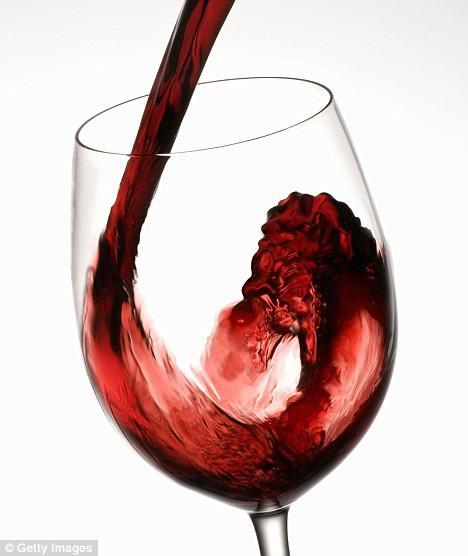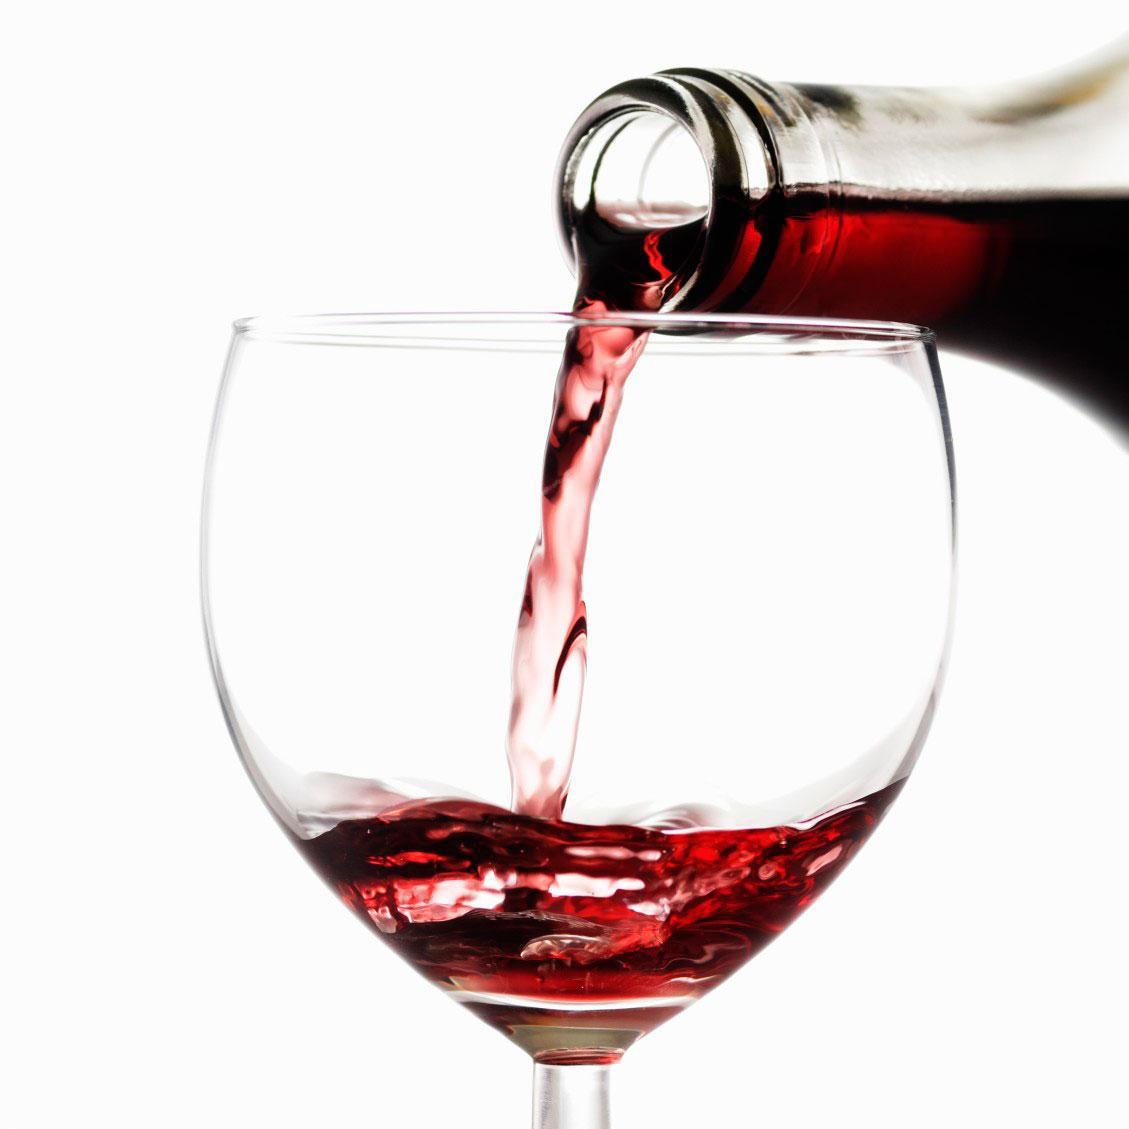The first image is the image on the left, the second image is the image on the right. Assess this claim about the two images: "wine bottles with a white background". Correct or not? Answer yes or no. No. The first image is the image on the left, the second image is the image on the right. For the images shown, is this caption "At least one of the images shows a sealed bottle of wine." true? Answer yes or no. No. 